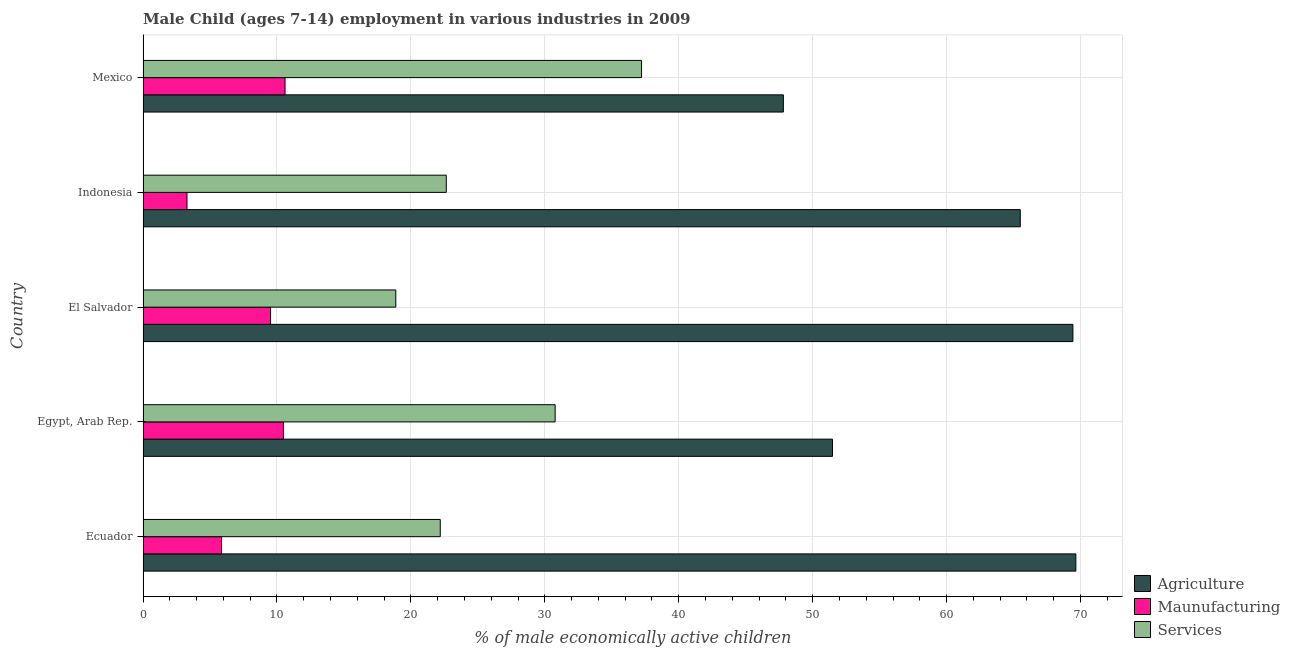How many groups of bars are there?
Ensure brevity in your answer.  5. Are the number of bars per tick equal to the number of legend labels?
Give a very brief answer. Yes. Are the number of bars on each tick of the Y-axis equal?
Give a very brief answer. Yes. How many bars are there on the 4th tick from the top?
Your answer should be very brief. 3. What is the label of the 4th group of bars from the top?
Give a very brief answer. Egypt, Arab Rep. What is the percentage of economically active children in services in Egypt, Arab Rep.?
Make the answer very short. 30.77. Across all countries, what is the maximum percentage of economically active children in manufacturing?
Your answer should be very brief. 10.6. Across all countries, what is the minimum percentage of economically active children in services?
Keep it short and to the point. 18.87. What is the total percentage of economically active children in agriculture in the graph?
Your response must be concise. 303.87. What is the difference between the percentage of economically active children in agriculture in Egypt, Arab Rep. and that in El Salvador?
Your response must be concise. -17.95. What is the difference between the percentage of economically active children in manufacturing in Mexico and the percentage of economically active children in services in El Salvador?
Keep it short and to the point. -8.27. What is the average percentage of economically active children in services per country?
Provide a short and direct response. 26.34. What is the difference between the percentage of economically active children in manufacturing and percentage of economically active children in services in Egypt, Arab Rep.?
Your response must be concise. -20.29. What is the ratio of the percentage of economically active children in manufacturing in Ecuador to that in Indonesia?
Give a very brief answer. 1.79. What is the difference between the highest and the second highest percentage of economically active children in manufacturing?
Make the answer very short. 0.12. What is the difference between the highest and the lowest percentage of economically active children in agriculture?
Give a very brief answer. 21.84. In how many countries, is the percentage of economically active children in services greater than the average percentage of economically active children in services taken over all countries?
Provide a succinct answer. 2. What does the 1st bar from the top in Mexico represents?
Your response must be concise. Services. What does the 1st bar from the bottom in Indonesia represents?
Provide a short and direct response. Agriculture. How many countries are there in the graph?
Your response must be concise. 5. What is the difference between two consecutive major ticks on the X-axis?
Provide a short and direct response. 10. Are the values on the major ticks of X-axis written in scientific E-notation?
Your answer should be compact. No. Does the graph contain any zero values?
Ensure brevity in your answer.  No. Where does the legend appear in the graph?
Ensure brevity in your answer.  Bottom right. How many legend labels are there?
Provide a short and direct response. 3. How are the legend labels stacked?
Ensure brevity in your answer.  Vertical. What is the title of the graph?
Keep it short and to the point. Male Child (ages 7-14) employment in various industries in 2009. Does "Secondary" appear as one of the legend labels in the graph?
Your answer should be compact. No. What is the label or title of the X-axis?
Keep it short and to the point. % of male economically active children. What is the label or title of the Y-axis?
Your answer should be compact. Country. What is the % of male economically active children of Agriculture in Ecuador?
Make the answer very short. 69.65. What is the % of male economically active children of Maunufacturing in Ecuador?
Offer a terse response. 5.86. What is the % of male economically active children of Services in Ecuador?
Give a very brief answer. 22.19. What is the % of male economically active children in Agriculture in Egypt, Arab Rep.?
Keep it short and to the point. 51.48. What is the % of male economically active children in Maunufacturing in Egypt, Arab Rep.?
Keep it short and to the point. 10.48. What is the % of male economically active children of Services in Egypt, Arab Rep.?
Your answer should be compact. 30.77. What is the % of male economically active children in Agriculture in El Salvador?
Provide a succinct answer. 69.43. What is the % of male economically active children in Maunufacturing in El Salvador?
Keep it short and to the point. 9.52. What is the % of male economically active children of Services in El Salvador?
Your answer should be compact. 18.87. What is the % of male economically active children in Agriculture in Indonesia?
Make the answer very short. 65.5. What is the % of male economically active children of Maunufacturing in Indonesia?
Provide a short and direct response. 3.28. What is the % of male economically active children of Services in Indonesia?
Keep it short and to the point. 22.64. What is the % of male economically active children of Agriculture in Mexico?
Keep it short and to the point. 47.81. What is the % of male economically active children of Services in Mexico?
Your answer should be very brief. 37.22. Across all countries, what is the maximum % of male economically active children of Agriculture?
Your answer should be compact. 69.65. Across all countries, what is the maximum % of male economically active children of Maunufacturing?
Offer a terse response. 10.6. Across all countries, what is the maximum % of male economically active children of Services?
Provide a short and direct response. 37.22. Across all countries, what is the minimum % of male economically active children of Agriculture?
Give a very brief answer. 47.81. Across all countries, what is the minimum % of male economically active children in Maunufacturing?
Offer a very short reply. 3.28. Across all countries, what is the minimum % of male economically active children of Services?
Make the answer very short. 18.87. What is the total % of male economically active children in Agriculture in the graph?
Ensure brevity in your answer.  303.87. What is the total % of male economically active children in Maunufacturing in the graph?
Offer a terse response. 39.74. What is the total % of male economically active children of Services in the graph?
Your answer should be very brief. 131.69. What is the difference between the % of male economically active children of Agriculture in Ecuador and that in Egypt, Arab Rep.?
Make the answer very short. 18.17. What is the difference between the % of male economically active children in Maunufacturing in Ecuador and that in Egypt, Arab Rep.?
Provide a succinct answer. -4.62. What is the difference between the % of male economically active children of Services in Ecuador and that in Egypt, Arab Rep.?
Your answer should be very brief. -8.58. What is the difference between the % of male economically active children of Agriculture in Ecuador and that in El Salvador?
Keep it short and to the point. 0.22. What is the difference between the % of male economically active children in Maunufacturing in Ecuador and that in El Salvador?
Make the answer very short. -3.66. What is the difference between the % of male economically active children of Services in Ecuador and that in El Salvador?
Your response must be concise. 3.32. What is the difference between the % of male economically active children of Agriculture in Ecuador and that in Indonesia?
Provide a succinct answer. 4.15. What is the difference between the % of male economically active children of Maunufacturing in Ecuador and that in Indonesia?
Your response must be concise. 2.58. What is the difference between the % of male economically active children in Services in Ecuador and that in Indonesia?
Your answer should be very brief. -0.45. What is the difference between the % of male economically active children in Agriculture in Ecuador and that in Mexico?
Your answer should be very brief. 21.84. What is the difference between the % of male economically active children in Maunufacturing in Ecuador and that in Mexico?
Give a very brief answer. -4.74. What is the difference between the % of male economically active children in Services in Ecuador and that in Mexico?
Keep it short and to the point. -15.03. What is the difference between the % of male economically active children in Agriculture in Egypt, Arab Rep. and that in El Salvador?
Offer a very short reply. -17.95. What is the difference between the % of male economically active children of Services in Egypt, Arab Rep. and that in El Salvador?
Offer a very short reply. 11.9. What is the difference between the % of male economically active children of Agriculture in Egypt, Arab Rep. and that in Indonesia?
Give a very brief answer. -14.02. What is the difference between the % of male economically active children of Maunufacturing in Egypt, Arab Rep. and that in Indonesia?
Give a very brief answer. 7.2. What is the difference between the % of male economically active children in Services in Egypt, Arab Rep. and that in Indonesia?
Your answer should be very brief. 8.13. What is the difference between the % of male economically active children in Agriculture in Egypt, Arab Rep. and that in Mexico?
Make the answer very short. 3.67. What is the difference between the % of male economically active children of Maunufacturing in Egypt, Arab Rep. and that in Mexico?
Your answer should be compact. -0.12. What is the difference between the % of male economically active children in Services in Egypt, Arab Rep. and that in Mexico?
Your response must be concise. -6.45. What is the difference between the % of male economically active children of Agriculture in El Salvador and that in Indonesia?
Offer a very short reply. 3.93. What is the difference between the % of male economically active children of Maunufacturing in El Salvador and that in Indonesia?
Keep it short and to the point. 6.24. What is the difference between the % of male economically active children in Services in El Salvador and that in Indonesia?
Your response must be concise. -3.77. What is the difference between the % of male economically active children of Agriculture in El Salvador and that in Mexico?
Your answer should be compact. 21.62. What is the difference between the % of male economically active children in Maunufacturing in El Salvador and that in Mexico?
Your response must be concise. -1.08. What is the difference between the % of male economically active children in Services in El Salvador and that in Mexico?
Provide a succinct answer. -18.35. What is the difference between the % of male economically active children in Agriculture in Indonesia and that in Mexico?
Provide a short and direct response. 17.69. What is the difference between the % of male economically active children of Maunufacturing in Indonesia and that in Mexico?
Give a very brief answer. -7.32. What is the difference between the % of male economically active children in Services in Indonesia and that in Mexico?
Provide a succinct answer. -14.58. What is the difference between the % of male economically active children in Agriculture in Ecuador and the % of male economically active children in Maunufacturing in Egypt, Arab Rep.?
Give a very brief answer. 59.17. What is the difference between the % of male economically active children of Agriculture in Ecuador and the % of male economically active children of Services in Egypt, Arab Rep.?
Ensure brevity in your answer.  38.88. What is the difference between the % of male economically active children in Maunufacturing in Ecuador and the % of male economically active children in Services in Egypt, Arab Rep.?
Provide a short and direct response. -24.91. What is the difference between the % of male economically active children of Agriculture in Ecuador and the % of male economically active children of Maunufacturing in El Salvador?
Your answer should be very brief. 60.13. What is the difference between the % of male economically active children of Agriculture in Ecuador and the % of male economically active children of Services in El Salvador?
Keep it short and to the point. 50.78. What is the difference between the % of male economically active children in Maunufacturing in Ecuador and the % of male economically active children in Services in El Salvador?
Your response must be concise. -13.01. What is the difference between the % of male economically active children in Agriculture in Ecuador and the % of male economically active children in Maunufacturing in Indonesia?
Your response must be concise. 66.37. What is the difference between the % of male economically active children in Agriculture in Ecuador and the % of male economically active children in Services in Indonesia?
Your response must be concise. 47.01. What is the difference between the % of male economically active children of Maunufacturing in Ecuador and the % of male economically active children of Services in Indonesia?
Make the answer very short. -16.78. What is the difference between the % of male economically active children of Agriculture in Ecuador and the % of male economically active children of Maunufacturing in Mexico?
Your answer should be compact. 59.05. What is the difference between the % of male economically active children in Agriculture in Ecuador and the % of male economically active children in Services in Mexico?
Keep it short and to the point. 32.43. What is the difference between the % of male economically active children in Maunufacturing in Ecuador and the % of male economically active children in Services in Mexico?
Your response must be concise. -31.36. What is the difference between the % of male economically active children in Agriculture in Egypt, Arab Rep. and the % of male economically active children in Maunufacturing in El Salvador?
Your answer should be compact. 41.96. What is the difference between the % of male economically active children in Agriculture in Egypt, Arab Rep. and the % of male economically active children in Services in El Salvador?
Offer a terse response. 32.61. What is the difference between the % of male economically active children of Maunufacturing in Egypt, Arab Rep. and the % of male economically active children of Services in El Salvador?
Your answer should be compact. -8.39. What is the difference between the % of male economically active children in Agriculture in Egypt, Arab Rep. and the % of male economically active children in Maunufacturing in Indonesia?
Your answer should be compact. 48.2. What is the difference between the % of male economically active children in Agriculture in Egypt, Arab Rep. and the % of male economically active children in Services in Indonesia?
Ensure brevity in your answer.  28.84. What is the difference between the % of male economically active children in Maunufacturing in Egypt, Arab Rep. and the % of male economically active children in Services in Indonesia?
Your answer should be compact. -12.16. What is the difference between the % of male economically active children in Agriculture in Egypt, Arab Rep. and the % of male economically active children in Maunufacturing in Mexico?
Keep it short and to the point. 40.88. What is the difference between the % of male economically active children in Agriculture in Egypt, Arab Rep. and the % of male economically active children in Services in Mexico?
Offer a terse response. 14.26. What is the difference between the % of male economically active children of Maunufacturing in Egypt, Arab Rep. and the % of male economically active children of Services in Mexico?
Make the answer very short. -26.74. What is the difference between the % of male economically active children of Agriculture in El Salvador and the % of male economically active children of Maunufacturing in Indonesia?
Your answer should be very brief. 66.15. What is the difference between the % of male economically active children in Agriculture in El Salvador and the % of male economically active children in Services in Indonesia?
Offer a very short reply. 46.79. What is the difference between the % of male economically active children of Maunufacturing in El Salvador and the % of male economically active children of Services in Indonesia?
Offer a terse response. -13.12. What is the difference between the % of male economically active children in Agriculture in El Salvador and the % of male economically active children in Maunufacturing in Mexico?
Provide a succinct answer. 58.83. What is the difference between the % of male economically active children of Agriculture in El Salvador and the % of male economically active children of Services in Mexico?
Your response must be concise. 32.21. What is the difference between the % of male economically active children in Maunufacturing in El Salvador and the % of male economically active children in Services in Mexico?
Keep it short and to the point. -27.7. What is the difference between the % of male economically active children of Agriculture in Indonesia and the % of male economically active children of Maunufacturing in Mexico?
Give a very brief answer. 54.9. What is the difference between the % of male economically active children in Agriculture in Indonesia and the % of male economically active children in Services in Mexico?
Offer a terse response. 28.28. What is the difference between the % of male economically active children of Maunufacturing in Indonesia and the % of male economically active children of Services in Mexico?
Ensure brevity in your answer.  -33.94. What is the average % of male economically active children of Agriculture per country?
Give a very brief answer. 60.77. What is the average % of male economically active children of Maunufacturing per country?
Your answer should be compact. 7.95. What is the average % of male economically active children in Services per country?
Provide a short and direct response. 26.34. What is the difference between the % of male economically active children of Agriculture and % of male economically active children of Maunufacturing in Ecuador?
Your answer should be compact. 63.79. What is the difference between the % of male economically active children of Agriculture and % of male economically active children of Services in Ecuador?
Make the answer very short. 47.46. What is the difference between the % of male economically active children in Maunufacturing and % of male economically active children in Services in Ecuador?
Your answer should be very brief. -16.33. What is the difference between the % of male economically active children of Agriculture and % of male economically active children of Maunufacturing in Egypt, Arab Rep.?
Make the answer very short. 41. What is the difference between the % of male economically active children in Agriculture and % of male economically active children in Services in Egypt, Arab Rep.?
Offer a very short reply. 20.71. What is the difference between the % of male economically active children of Maunufacturing and % of male economically active children of Services in Egypt, Arab Rep.?
Keep it short and to the point. -20.29. What is the difference between the % of male economically active children in Agriculture and % of male economically active children in Maunufacturing in El Salvador?
Offer a terse response. 59.91. What is the difference between the % of male economically active children of Agriculture and % of male economically active children of Services in El Salvador?
Keep it short and to the point. 50.56. What is the difference between the % of male economically active children in Maunufacturing and % of male economically active children in Services in El Salvador?
Provide a short and direct response. -9.35. What is the difference between the % of male economically active children of Agriculture and % of male economically active children of Maunufacturing in Indonesia?
Offer a terse response. 62.22. What is the difference between the % of male economically active children of Agriculture and % of male economically active children of Services in Indonesia?
Offer a very short reply. 42.86. What is the difference between the % of male economically active children in Maunufacturing and % of male economically active children in Services in Indonesia?
Your answer should be compact. -19.36. What is the difference between the % of male economically active children in Agriculture and % of male economically active children in Maunufacturing in Mexico?
Provide a succinct answer. 37.21. What is the difference between the % of male economically active children in Agriculture and % of male economically active children in Services in Mexico?
Your answer should be very brief. 10.59. What is the difference between the % of male economically active children of Maunufacturing and % of male economically active children of Services in Mexico?
Offer a very short reply. -26.62. What is the ratio of the % of male economically active children in Agriculture in Ecuador to that in Egypt, Arab Rep.?
Give a very brief answer. 1.35. What is the ratio of the % of male economically active children of Maunufacturing in Ecuador to that in Egypt, Arab Rep.?
Provide a short and direct response. 0.56. What is the ratio of the % of male economically active children of Services in Ecuador to that in Egypt, Arab Rep.?
Ensure brevity in your answer.  0.72. What is the ratio of the % of male economically active children of Agriculture in Ecuador to that in El Salvador?
Your response must be concise. 1. What is the ratio of the % of male economically active children in Maunufacturing in Ecuador to that in El Salvador?
Your answer should be compact. 0.62. What is the ratio of the % of male economically active children in Services in Ecuador to that in El Salvador?
Offer a terse response. 1.18. What is the ratio of the % of male economically active children in Agriculture in Ecuador to that in Indonesia?
Provide a short and direct response. 1.06. What is the ratio of the % of male economically active children of Maunufacturing in Ecuador to that in Indonesia?
Provide a succinct answer. 1.79. What is the ratio of the % of male economically active children of Services in Ecuador to that in Indonesia?
Make the answer very short. 0.98. What is the ratio of the % of male economically active children of Agriculture in Ecuador to that in Mexico?
Give a very brief answer. 1.46. What is the ratio of the % of male economically active children of Maunufacturing in Ecuador to that in Mexico?
Offer a very short reply. 0.55. What is the ratio of the % of male economically active children of Services in Ecuador to that in Mexico?
Offer a terse response. 0.6. What is the ratio of the % of male economically active children in Agriculture in Egypt, Arab Rep. to that in El Salvador?
Your answer should be very brief. 0.74. What is the ratio of the % of male economically active children in Maunufacturing in Egypt, Arab Rep. to that in El Salvador?
Provide a short and direct response. 1.1. What is the ratio of the % of male economically active children in Services in Egypt, Arab Rep. to that in El Salvador?
Provide a succinct answer. 1.63. What is the ratio of the % of male economically active children in Agriculture in Egypt, Arab Rep. to that in Indonesia?
Keep it short and to the point. 0.79. What is the ratio of the % of male economically active children in Maunufacturing in Egypt, Arab Rep. to that in Indonesia?
Make the answer very short. 3.2. What is the ratio of the % of male economically active children in Services in Egypt, Arab Rep. to that in Indonesia?
Provide a short and direct response. 1.36. What is the ratio of the % of male economically active children in Agriculture in Egypt, Arab Rep. to that in Mexico?
Keep it short and to the point. 1.08. What is the ratio of the % of male economically active children of Maunufacturing in Egypt, Arab Rep. to that in Mexico?
Ensure brevity in your answer.  0.99. What is the ratio of the % of male economically active children of Services in Egypt, Arab Rep. to that in Mexico?
Your answer should be very brief. 0.83. What is the ratio of the % of male economically active children in Agriculture in El Salvador to that in Indonesia?
Provide a short and direct response. 1.06. What is the ratio of the % of male economically active children in Maunufacturing in El Salvador to that in Indonesia?
Keep it short and to the point. 2.9. What is the ratio of the % of male economically active children of Services in El Salvador to that in Indonesia?
Offer a very short reply. 0.83. What is the ratio of the % of male economically active children of Agriculture in El Salvador to that in Mexico?
Offer a terse response. 1.45. What is the ratio of the % of male economically active children of Maunufacturing in El Salvador to that in Mexico?
Offer a very short reply. 0.9. What is the ratio of the % of male economically active children in Services in El Salvador to that in Mexico?
Offer a terse response. 0.51. What is the ratio of the % of male economically active children of Agriculture in Indonesia to that in Mexico?
Keep it short and to the point. 1.37. What is the ratio of the % of male economically active children of Maunufacturing in Indonesia to that in Mexico?
Your response must be concise. 0.31. What is the ratio of the % of male economically active children of Services in Indonesia to that in Mexico?
Keep it short and to the point. 0.61. What is the difference between the highest and the second highest % of male economically active children in Agriculture?
Your answer should be compact. 0.22. What is the difference between the highest and the second highest % of male economically active children in Maunufacturing?
Keep it short and to the point. 0.12. What is the difference between the highest and the second highest % of male economically active children in Services?
Provide a succinct answer. 6.45. What is the difference between the highest and the lowest % of male economically active children of Agriculture?
Offer a very short reply. 21.84. What is the difference between the highest and the lowest % of male economically active children of Maunufacturing?
Your answer should be very brief. 7.32. What is the difference between the highest and the lowest % of male economically active children of Services?
Offer a terse response. 18.35. 